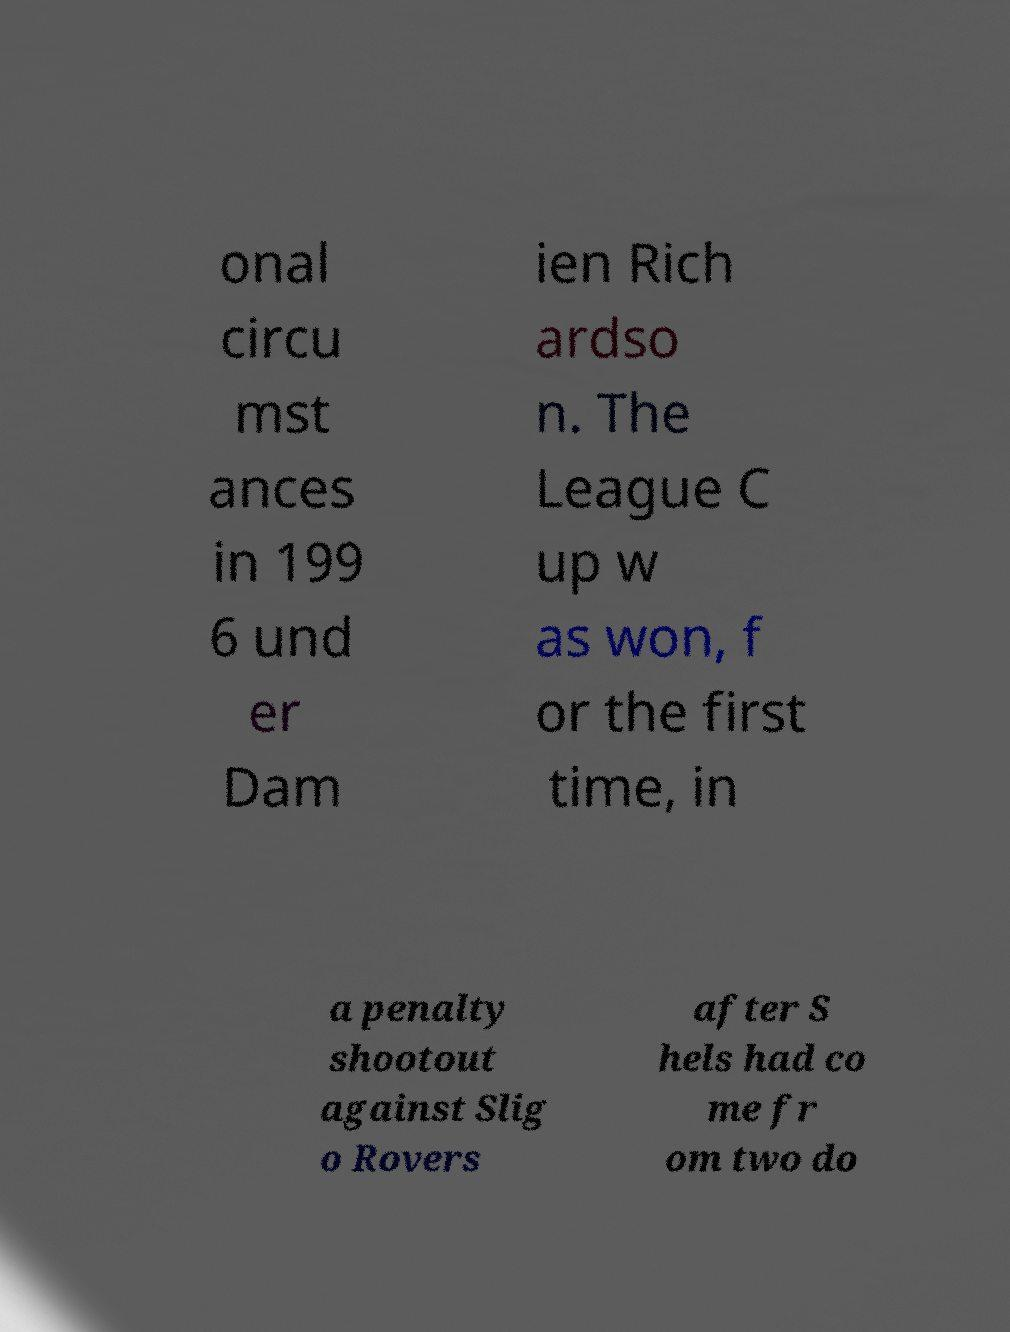What messages or text are displayed in this image? I need them in a readable, typed format. onal circu mst ances in 199 6 und er Dam ien Rich ardso n. The League C up w as won, f or the first time, in a penalty shootout against Slig o Rovers after S hels had co me fr om two do 